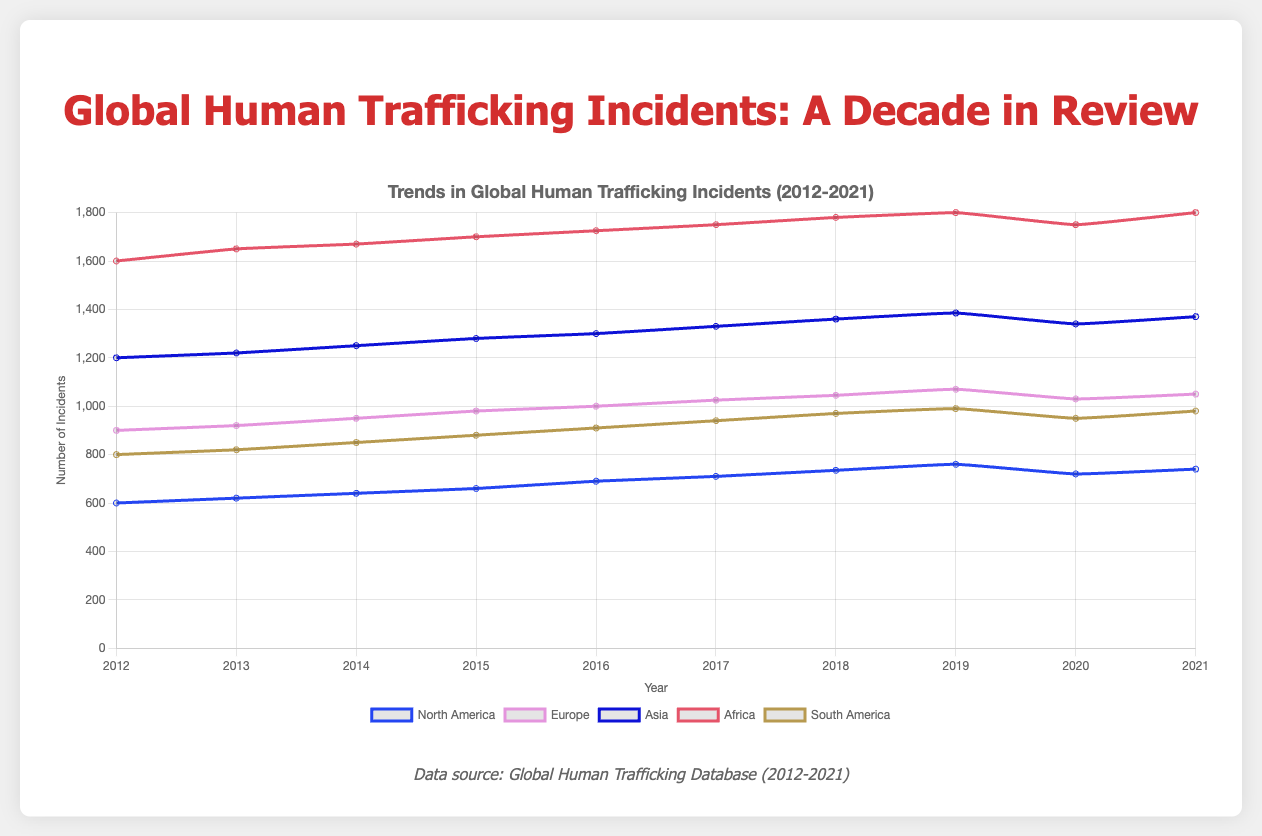How has the number of human trafficking incidents in Europe changed from 2012 to 2021? To determine the change in incidents in Europe, compare the data points for 2012 and 2021. In 2012, incidents were 900 and in 2021 they were 1050. The increase is calculated as 1050 - 900 = 150.
Answer: Increased by 150 Which region had the highest number of human trafficking incidents in 2016? Comparing the incidents in 2016 across all regions: North America (690), Europe (1000), Asia (1300), Africa (1725), South America (910), Africa had the highest number of incidents.
Answer: Africa What is the average number of human trafficking incidents in North America from 2012 to 2021? Sum the incidents for North America from 2012 to 2021 and divide by the number of years. (600 + 620 + 640 + 660 + 690 + 710 + 735 + 760 + 720 + 740) / 10 = 6875 / 10 = 687.5
Answer: 687.5 Compare the trends in human trafficking incidents between Asia and South America from 2012 to 2021. Which region shows a greater increase in incidents over this period? Calculate the change for both regions. Asia (2012: 1200, 2021: 1370) change is 1370 - 1200 = 170. South America (2012: 800, 2021: 980) change is 980 - 800 = 180. South America shows a greater increase in incidents.
Answer: South America What year did North America see its highest number of human trafficking incidents? Reviewing the data for North America across the years, the highest number of incidents is in 2019 with 760 incidents.
Answer: 2019 Which region experienced a drop in human trafficking incidents between 2019 and 2020? Compare the incidents in 2019 and 2020 for each region: North America (760 to 720), Europe (1070 to 1030), Asia (1385 to 1340), Africa (1800 to 1750), South America (990 to 950). All regions experienced a decrease.
Answer: All regions How did the number of incidents in Africa change from 2019 to 2021? Was there a recovery in the number of incidents? Incidents in Africa were 1800 in 2019, dropped to 1750 in 2020, and were 1800 again in 2021. This shows a recovery in the number of incidents to the 2019 level.
Answer: Recovered What is the total number of human trafficking incidents reported in Asia over the decade from 2012 to 2021? Sum the incidents in Asia for all years from 2012 to 2021. 1200 + 1220 + 1250 + 1280 + 1300 + 1330 + 1360 + 1385 + 1340 + 1370 = 13035.
Answer: 13035 Which region saw the least fluctuation in the number of incidents from 2012 to 2021, considering minimal variance in the yearly data points? Assess the variance in incidents for each region to determine the least fluctuation. Minimal variance indicates the most stable trend. North America shows the least fluctuation with minor yearly changes.
Answer: North America Between 2012 and 2021, which year saw the highest total number of human trafficking incidents globally? Sum the incidents of all regions for each year and compare. 2019 has the highest total: North America (760) + Europe (1070) + Asia (1385) + Africa (1800) + South America (990) = 6005.
Answer: 2019 